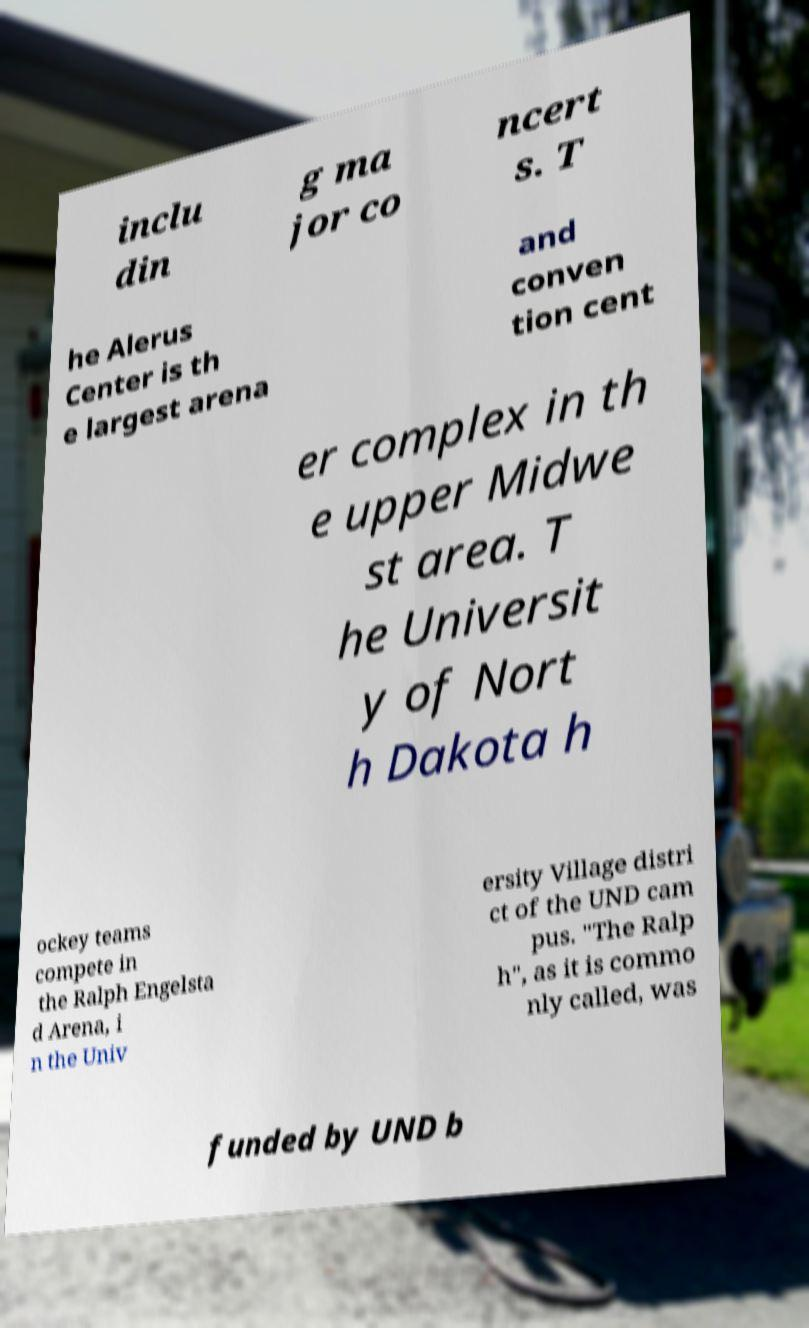I need the written content from this picture converted into text. Can you do that? inclu din g ma jor co ncert s. T he Alerus Center is th e largest arena and conven tion cent er complex in th e upper Midwe st area. T he Universit y of Nort h Dakota h ockey teams compete in the Ralph Engelsta d Arena, i n the Univ ersity Village distri ct of the UND cam pus. "The Ralp h", as it is commo nly called, was funded by UND b 